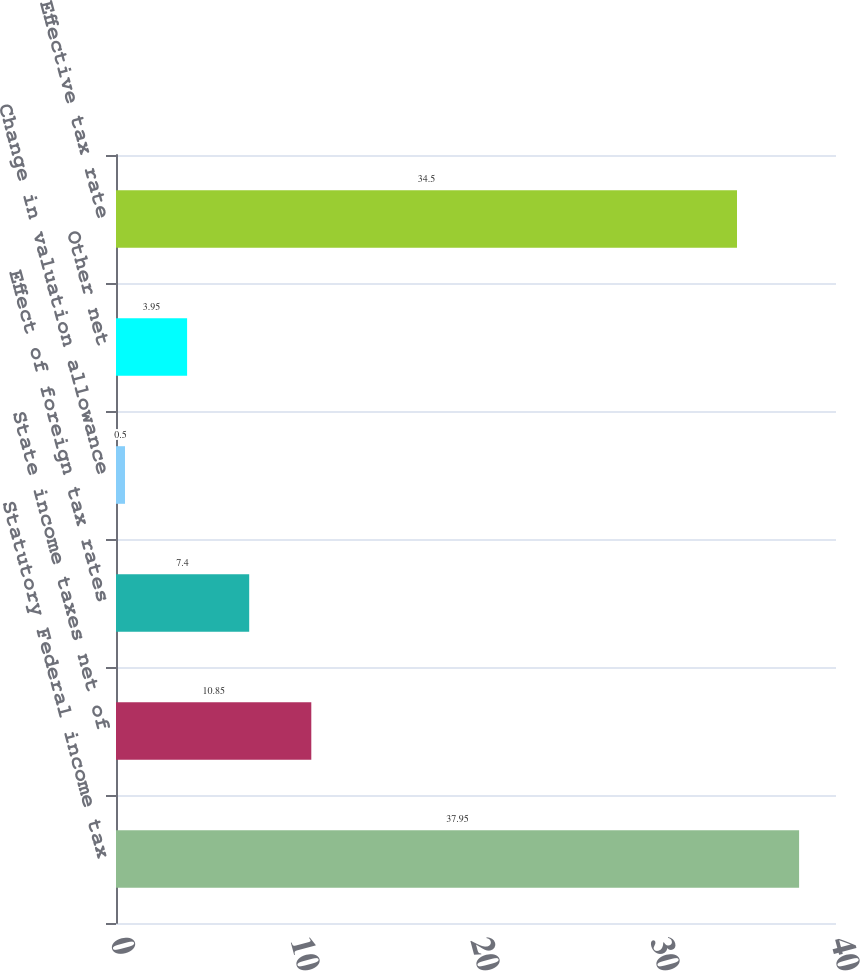<chart> <loc_0><loc_0><loc_500><loc_500><bar_chart><fcel>Statutory Federal income tax<fcel>State income taxes net of<fcel>Effect of foreign tax rates<fcel>Change in valuation allowance<fcel>Other net<fcel>Effective tax rate<nl><fcel>37.95<fcel>10.85<fcel>7.4<fcel>0.5<fcel>3.95<fcel>34.5<nl></chart> 